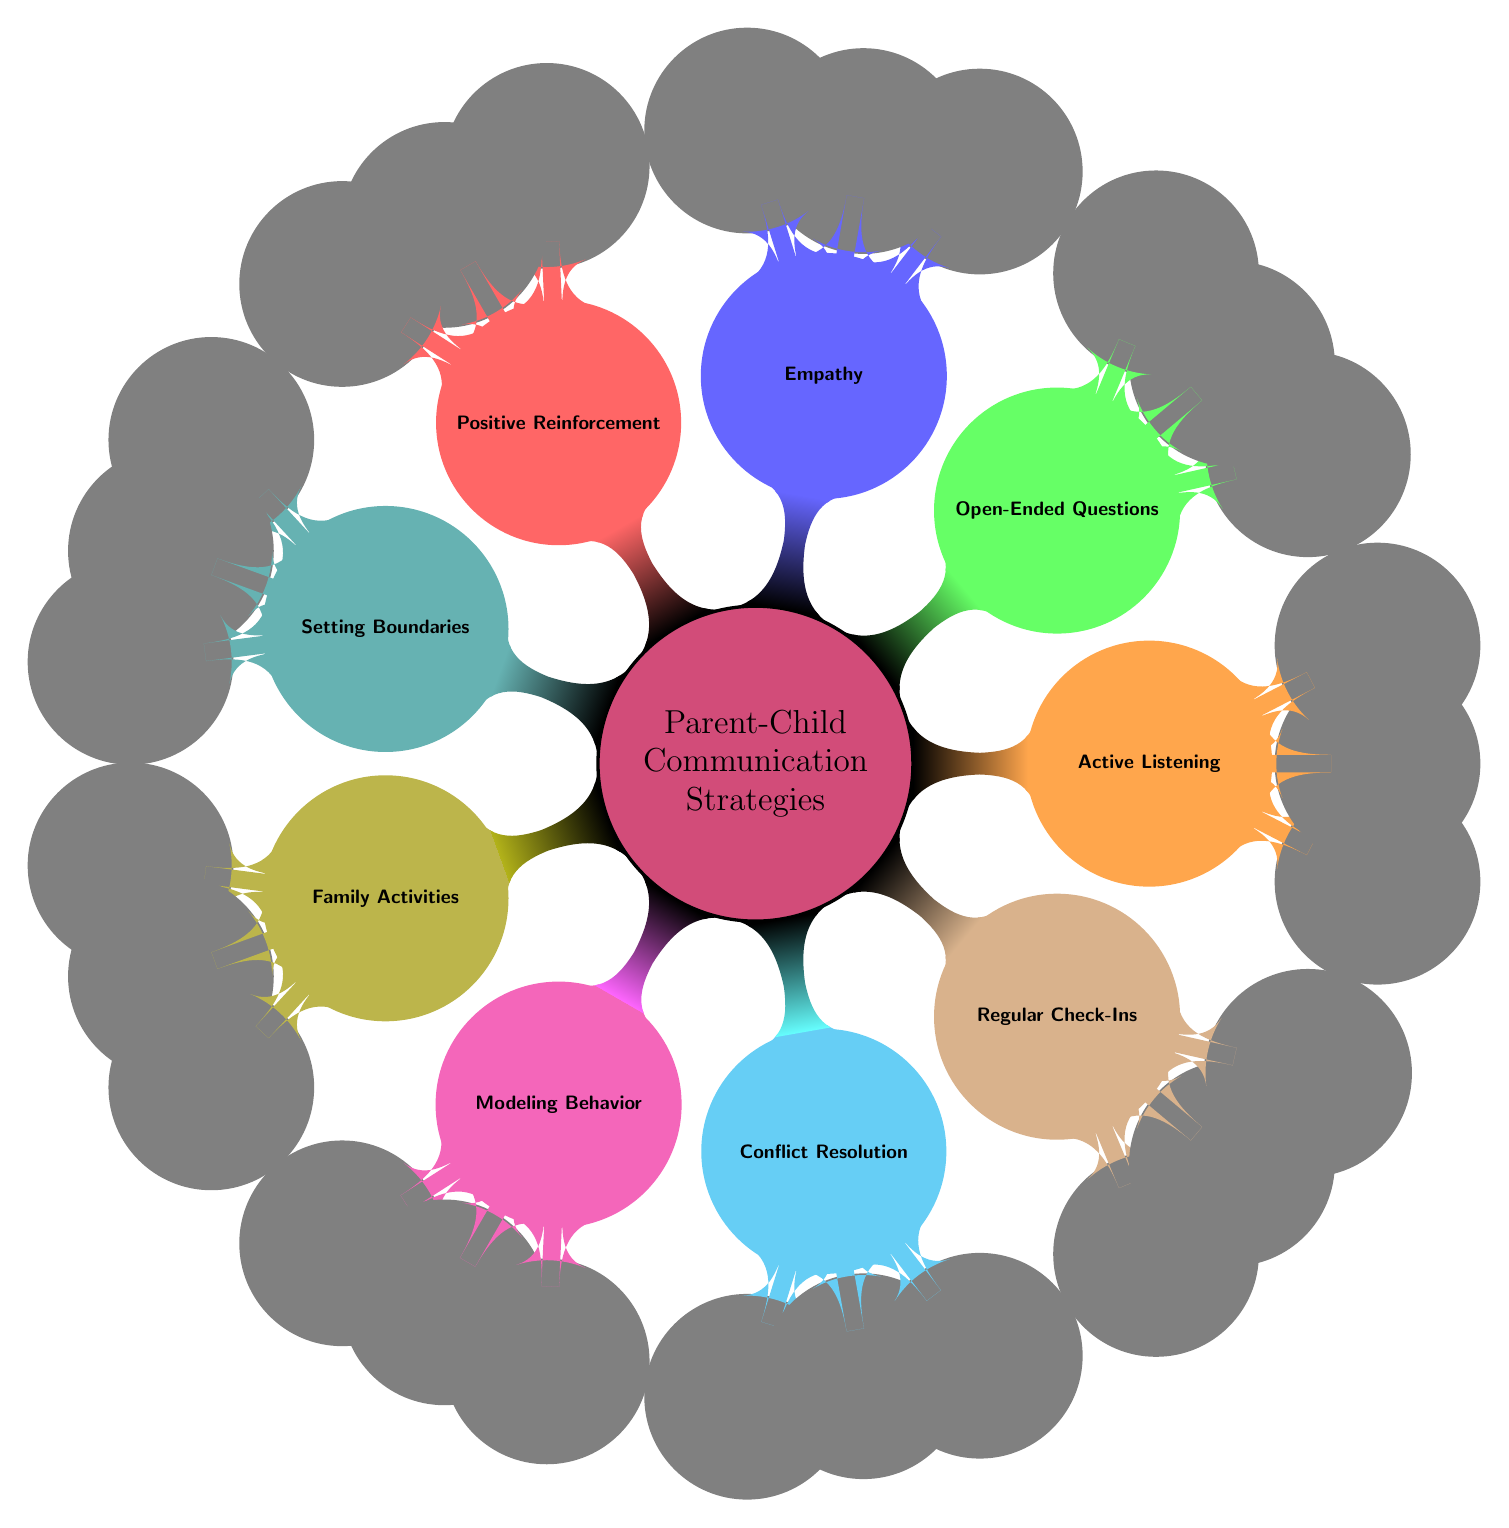What is the main topic of the mind map? The diagram clearly identifies "Parent-Child Communication Strategies" as the central concept at the top of the diagram, indicating the overarching theme.
Answer: Parent-Child Communication Strategies How many primary strategies are listed in the diagram? By counting each main child node directly connected to the central node, there are eight primary strategies represented in the diagram.
Answer: 8 What is one technique listed under Active Listening? The diagram shows several techniques under Active Listening; one identified technique is "Reflective Responses."
Answer: Reflective Responses Which strategy emphasizes discussing feelings? Looking at the node structure, "Empathy" is the strategy that emphasizes acknowledging and discussing feelings with children.
Answer: Empathy What does the Family Activities node suggest is one way to strengthen communication? This node includes suggestions such as "Family Outings," which imply that shared activities can enhance communication within families.
Answer: Family Outings Which strategy contains a method for addressing disputes? The "Conflict Resolution" strategy is specifically aimed at providing methods to address disputes, such as "Fair Negotiation."
Answer: Conflict Resolution Under which strategy would you find "Praise Effort"? Following the branches of the diagram, "Praise Effort" is a technique under the "Positive Reinforcement" strategy.
Answer: Positive Reinforcement What is the significance of Regular Check-Ins in the context of this diagram? Regular Check-Ins are highlighted as essential for maintaining ongoing communication and connection; examples include "Weekly Meetings."
Answer: Weekly Meetings How many techniques are listed under the Setting Boundaries strategy? Upon reviewing the child nodes under "Setting Boundaries," there are three techniques provided: "Consistent Rules," "Clear Consequences," and "Age-Appropriate Expectations."
Answer: 3 